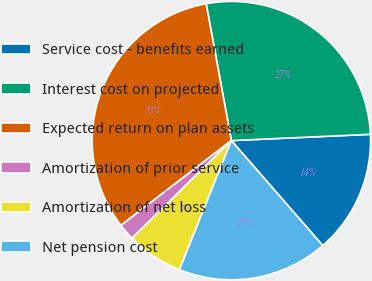<chart> <loc_0><loc_0><loc_500><loc_500><pie_chart><fcel>Service cost - benefits earned<fcel>Interest cost on projected<fcel>Expected return on plan assets<fcel>Amortization of prior service<fcel>Amortization of net loss<fcel>Net pension cost<nl><fcel>14.32%<fcel>27.18%<fcel>32.52%<fcel>1.94%<fcel>6.55%<fcel>17.48%<nl></chart> 